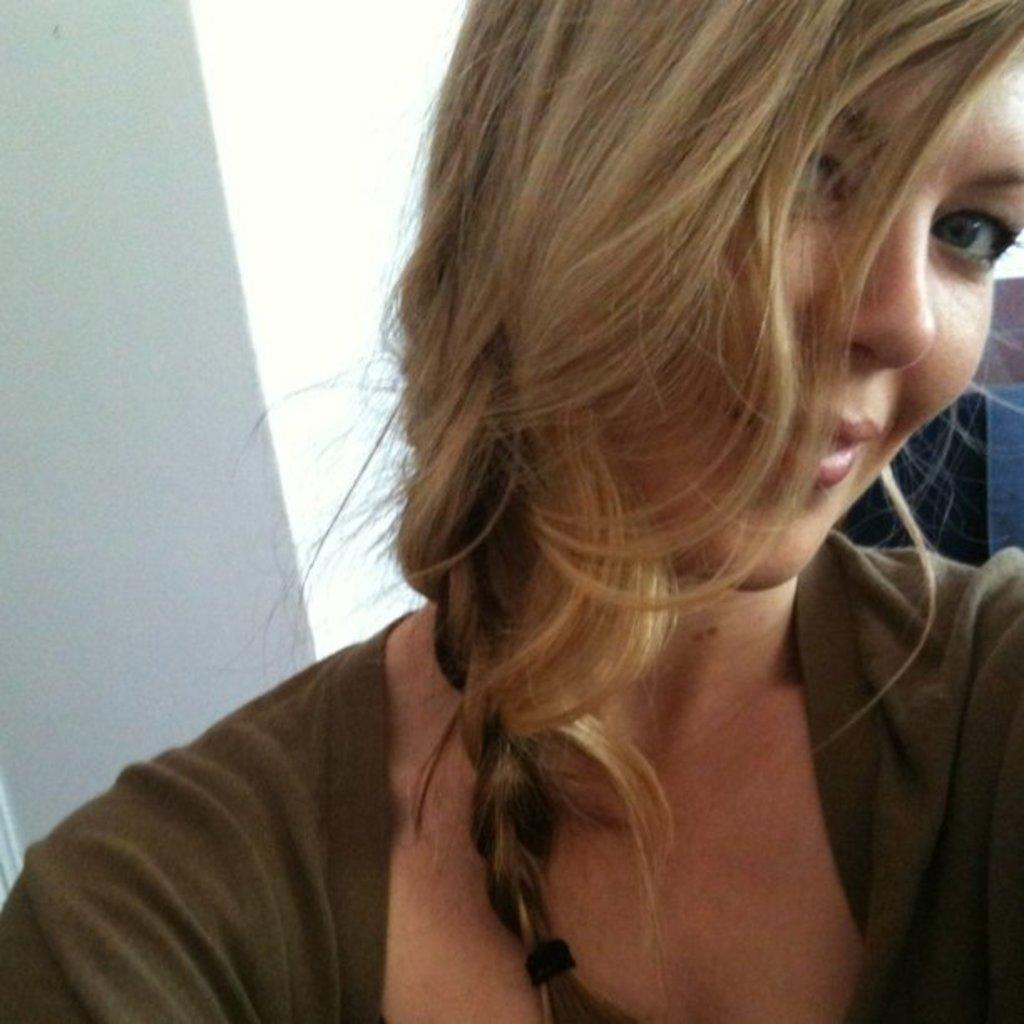Who is present in the image? There is a woman in the image. What is the woman wearing? The woman is wearing a green dress. What can be seen behind the woman? There is a white wall behind the woman. What religion does the group in the image practice? There is no group present in the image, only a woman. How many elbows can be seen in the image? There are no elbows visible in the image, as it only features a woman. 